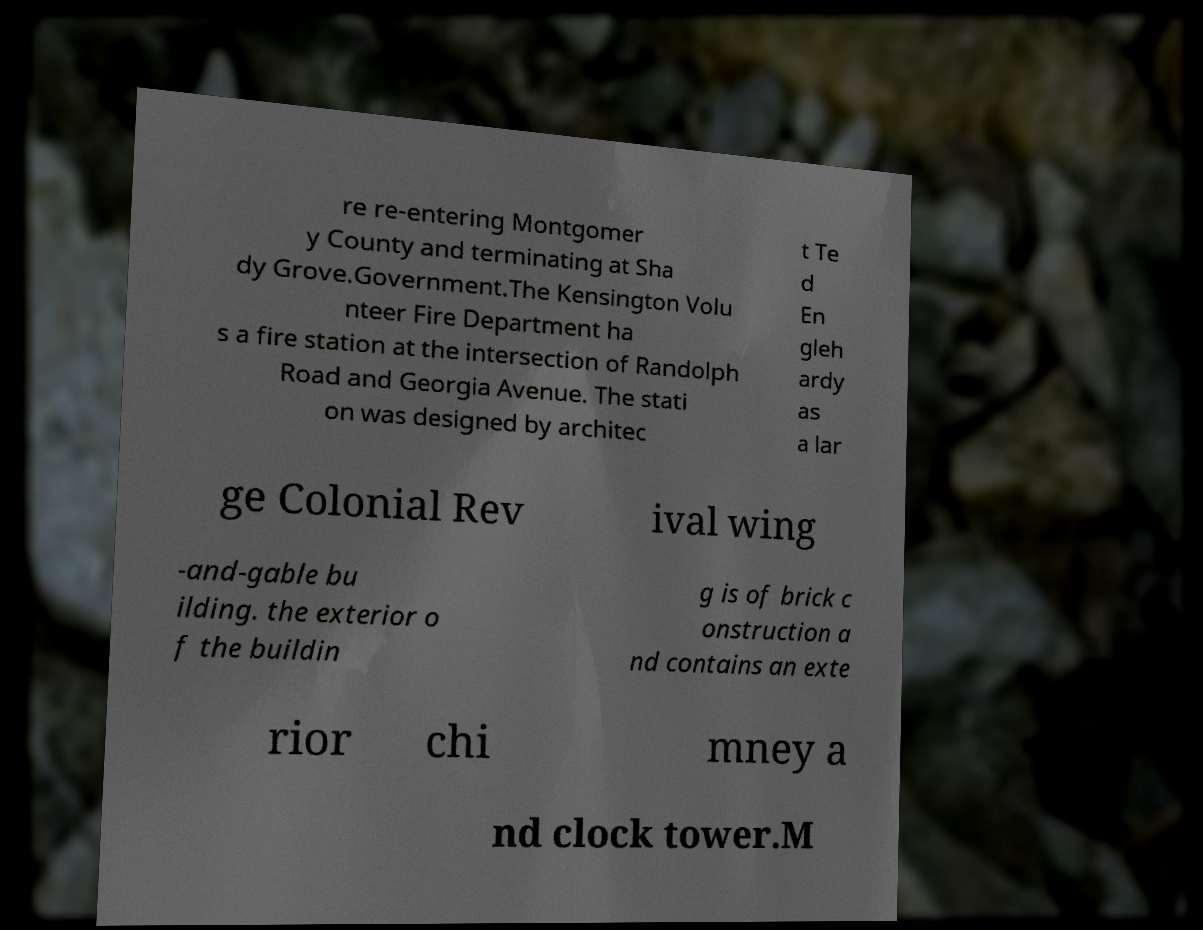Please identify and transcribe the text found in this image. re re-entering Montgomer y County and terminating at Sha dy Grove.Government.The Kensington Volu nteer Fire Department ha s a fire station at the intersection of Randolph Road and Georgia Avenue. The stati on was designed by architec t Te d En gleh ardy as a lar ge Colonial Rev ival wing -and-gable bu ilding. the exterior o f the buildin g is of brick c onstruction a nd contains an exte rior chi mney a nd clock tower.M 